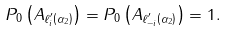Convert formula to latex. <formula><loc_0><loc_0><loc_500><loc_500>P _ { 0 } \left ( A _ { \ell ^ { \prime } _ { i } \left ( \alpha _ { 2 } \right ) } \right ) = P _ { 0 } \left ( A _ { \ell ^ { \prime } _ { - i } \left ( \alpha _ { 2 } \right ) } \right ) = 1 .</formula> 